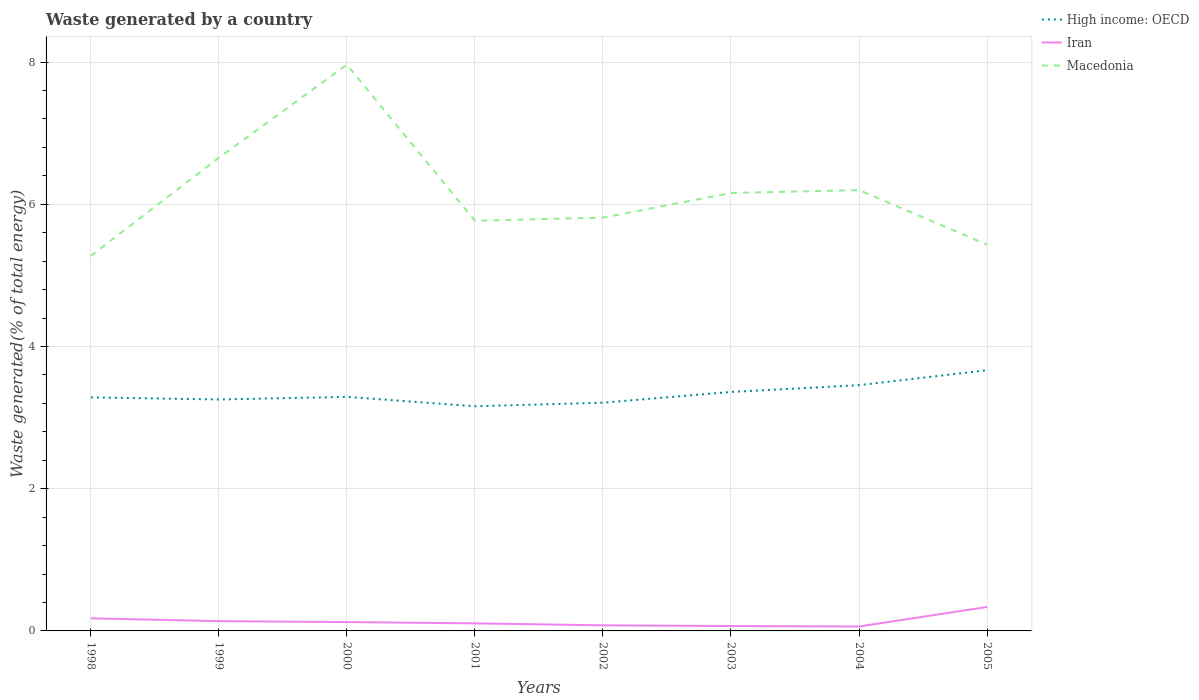Across all years, what is the maximum total waste generated in High income: OECD?
Ensure brevity in your answer.  3.16. What is the total total waste generated in Macedonia in the graph?
Give a very brief answer. -0.49. What is the difference between the highest and the second highest total waste generated in Macedonia?
Keep it short and to the point. 2.69. What is the difference between the highest and the lowest total waste generated in Iran?
Your answer should be compact. 3. Is the total waste generated in Macedonia strictly greater than the total waste generated in High income: OECD over the years?
Your answer should be compact. No. How many lines are there?
Provide a succinct answer. 3. How many years are there in the graph?
Ensure brevity in your answer.  8. What is the difference between two consecutive major ticks on the Y-axis?
Make the answer very short. 2. Where does the legend appear in the graph?
Your answer should be compact. Top right. How are the legend labels stacked?
Your response must be concise. Vertical. What is the title of the graph?
Offer a very short reply. Waste generated by a country. Does "Libya" appear as one of the legend labels in the graph?
Provide a succinct answer. No. What is the label or title of the Y-axis?
Ensure brevity in your answer.  Waste generated(% of total energy). What is the Waste generated(% of total energy) of High income: OECD in 1998?
Provide a short and direct response. 3.28. What is the Waste generated(% of total energy) in Iran in 1998?
Your response must be concise. 0.18. What is the Waste generated(% of total energy) of Macedonia in 1998?
Offer a very short reply. 5.27. What is the Waste generated(% of total energy) in High income: OECD in 1999?
Offer a terse response. 3.26. What is the Waste generated(% of total energy) of Iran in 1999?
Ensure brevity in your answer.  0.14. What is the Waste generated(% of total energy) in Macedonia in 1999?
Make the answer very short. 6.66. What is the Waste generated(% of total energy) in High income: OECD in 2000?
Provide a succinct answer. 3.29. What is the Waste generated(% of total energy) of Iran in 2000?
Offer a terse response. 0.12. What is the Waste generated(% of total energy) of Macedonia in 2000?
Offer a terse response. 7.96. What is the Waste generated(% of total energy) of High income: OECD in 2001?
Your response must be concise. 3.16. What is the Waste generated(% of total energy) of Iran in 2001?
Your answer should be very brief. 0.11. What is the Waste generated(% of total energy) in Macedonia in 2001?
Give a very brief answer. 5.77. What is the Waste generated(% of total energy) of High income: OECD in 2002?
Give a very brief answer. 3.21. What is the Waste generated(% of total energy) in Iran in 2002?
Offer a very short reply. 0.08. What is the Waste generated(% of total energy) of Macedonia in 2002?
Ensure brevity in your answer.  5.81. What is the Waste generated(% of total energy) of High income: OECD in 2003?
Your response must be concise. 3.36. What is the Waste generated(% of total energy) of Iran in 2003?
Your answer should be very brief. 0.07. What is the Waste generated(% of total energy) in Macedonia in 2003?
Make the answer very short. 6.16. What is the Waste generated(% of total energy) of High income: OECD in 2004?
Offer a very short reply. 3.46. What is the Waste generated(% of total energy) in Iran in 2004?
Your answer should be very brief. 0.06. What is the Waste generated(% of total energy) of Macedonia in 2004?
Provide a succinct answer. 6.2. What is the Waste generated(% of total energy) in High income: OECD in 2005?
Make the answer very short. 3.67. What is the Waste generated(% of total energy) of Iran in 2005?
Keep it short and to the point. 0.34. What is the Waste generated(% of total energy) of Macedonia in 2005?
Ensure brevity in your answer.  5.43. Across all years, what is the maximum Waste generated(% of total energy) in High income: OECD?
Your response must be concise. 3.67. Across all years, what is the maximum Waste generated(% of total energy) in Iran?
Your answer should be compact. 0.34. Across all years, what is the maximum Waste generated(% of total energy) in Macedonia?
Offer a very short reply. 7.96. Across all years, what is the minimum Waste generated(% of total energy) in High income: OECD?
Ensure brevity in your answer.  3.16. Across all years, what is the minimum Waste generated(% of total energy) of Iran?
Your answer should be very brief. 0.06. Across all years, what is the minimum Waste generated(% of total energy) of Macedonia?
Make the answer very short. 5.27. What is the total Waste generated(% of total energy) in High income: OECD in the graph?
Offer a terse response. 26.69. What is the total Waste generated(% of total energy) of Iran in the graph?
Ensure brevity in your answer.  1.09. What is the total Waste generated(% of total energy) in Macedonia in the graph?
Provide a short and direct response. 49.27. What is the difference between the Waste generated(% of total energy) in High income: OECD in 1998 and that in 1999?
Make the answer very short. 0.03. What is the difference between the Waste generated(% of total energy) in Iran in 1998 and that in 1999?
Give a very brief answer. 0.04. What is the difference between the Waste generated(% of total energy) of Macedonia in 1998 and that in 1999?
Your answer should be compact. -1.38. What is the difference between the Waste generated(% of total energy) in High income: OECD in 1998 and that in 2000?
Your response must be concise. -0.01. What is the difference between the Waste generated(% of total energy) in Iran in 1998 and that in 2000?
Make the answer very short. 0.05. What is the difference between the Waste generated(% of total energy) of Macedonia in 1998 and that in 2000?
Provide a short and direct response. -2.69. What is the difference between the Waste generated(% of total energy) in High income: OECD in 1998 and that in 2001?
Make the answer very short. 0.13. What is the difference between the Waste generated(% of total energy) in Iran in 1998 and that in 2001?
Offer a terse response. 0.07. What is the difference between the Waste generated(% of total energy) of Macedonia in 1998 and that in 2001?
Make the answer very short. -0.49. What is the difference between the Waste generated(% of total energy) in High income: OECD in 1998 and that in 2002?
Provide a short and direct response. 0.07. What is the difference between the Waste generated(% of total energy) in Iran in 1998 and that in 2002?
Your answer should be very brief. 0.1. What is the difference between the Waste generated(% of total energy) in Macedonia in 1998 and that in 2002?
Make the answer very short. -0.54. What is the difference between the Waste generated(% of total energy) in High income: OECD in 1998 and that in 2003?
Provide a succinct answer. -0.08. What is the difference between the Waste generated(% of total energy) in Iran in 1998 and that in 2003?
Make the answer very short. 0.11. What is the difference between the Waste generated(% of total energy) of Macedonia in 1998 and that in 2003?
Your answer should be compact. -0.88. What is the difference between the Waste generated(% of total energy) in High income: OECD in 1998 and that in 2004?
Your response must be concise. -0.17. What is the difference between the Waste generated(% of total energy) of Iran in 1998 and that in 2004?
Provide a short and direct response. 0.12. What is the difference between the Waste generated(% of total energy) of Macedonia in 1998 and that in 2004?
Provide a short and direct response. -0.93. What is the difference between the Waste generated(% of total energy) in High income: OECD in 1998 and that in 2005?
Ensure brevity in your answer.  -0.38. What is the difference between the Waste generated(% of total energy) of Iran in 1998 and that in 2005?
Your answer should be compact. -0.16. What is the difference between the Waste generated(% of total energy) of Macedonia in 1998 and that in 2005?
Keep it short and to the point. -0.16. What is the difference between the Waste generated(% of total energy) of High income: OECD in 1999 and that in 2000?
Your answer should be very brief. -0.04. What is the difference between the Waste generated(% of total energy) of Iran in 1999 and that in 2000?
Provide a succinct answer. 0.01. What is the difference between the Waste generated(% of total energy) in Macedonia in 1999 and that in 2000?
Your answer should be very brief. -1.31. What is the difference between the Waste generated(% of total energy) of High income: OECD in 1999 and that in 2001?
Keep it short and to the point. 0.1. What is the difference between the Waste generated(% of total energy) of Iran in 1999 and that in 2001?
Your response must be concise. 0.03. What is the difference between the Waste generated(% of total energy) of Macedonia in 1999 and that in 2001?
Offer a very short reply. 0.89. What is the difference between the Waste generated(% of total energy) in High income: OECD in 1999 and that in 2002?
Offer a terse response. 0.04. What is the difference between the Waste generated(% of total energy) in Iran in 1999 and that in 2002?
Provide a short and direct response. 0.06. What is the difference between the Waste generated(% of total energy) of Macedonia in 1999 and that in 2002?
Ensure brevity in your answer.  0.84. What is the difference between the Waste generated(% of total energy) of High income: OECD in 1999 and that in 2003?
Your response must be concise. -0.11. What is the difference between the Waste generated(% of total energy) of Iran in 1999 and that in 2003?
Make the answer very short. 0.07. What is the difference between the Waste generated(% of total energy) in Macedonia in 1999 and that in 2003?
Provide a short and direct response. 0.5. What is the difference between the Waste generated(% of total energy) in High income: OECD in 1999 and that in 2004?
Ensure brevity in your answer.  -0.2. What is the difference between the Waste generated(% of total energy) in Iran in 1999 and that in 2004?
Provide a succinct answer. 0.08. What is the difference between the Waste generated(% of total energy) of Macedonia in 1999 and that in 2004?
Offer a terse response. 0.46. What is the difference between the Waste generated(% of total energy) of High income: OECD in 1999 and that in 2005?
Provide a succinct answer. -0.41. What is the difference between the Waste generated(% of total energy) of Iran in 1999 and that in 2005?
Your answer should be compact. -0.2. What is the difference between the Waste generated(% of total energy) in Macedonia in 1999 and that in 2005?
Ensure brevity in your answer.  1.22. What is the difference between the Waste generated(% of total energy) in High income: OECD in 2000 and that in 2001?
Your answer should be compact. 0.13. What is the difference between the Waste generated(% of total energy) of Iran in 2000 and that in 2001?
Your answer should be very brief. 0.02. What is the difference between the Waste generated(% of total energy) in Macedonia in 2000 and that in 2001?
Your answer should be very brief. 2.2. What is the difference between the Waste generated(% of total energy) of High income: OECD in 2000 and that in 2002?
Your answer should be compact. 0.08. What is the difference between the Waste generated(% of total energy) of Iran in 2000 and that in 2002?
Offer a very short reply. 0.05. What is the difference between the Waste generated(% of total energy) in Macedonia in 2000 and that in 2002?
Give a very brief answer. 2.15. What is the difference between the Waste generated(% of total energy) in High income: OECD in 2000 and that in 2003?
Offer a terse response. -0.07. What is the difference between the Waste generated(% of total energy) in Iran in 2000 and that in 2003?
Ensure brevity in your answer.  0.06. What is the difference between the Waste generated(% of total energy) in Macedonia in 2000 and that in 2003?
Keep it short and to the point. 1.8. What is the difference between the Waste generated(% of total energy) in High income: OECD in 2000 and that in 2004?
Your answer should be compact. -0.16. What is the difference between the Waste generated(% of total energy) of Iran in 2000 and that in 2004?
Give a very brief answer. 0.06. What is the difference between the Waste generated(% of total energy) in Macedonia in 2000 and that in 2004?
Give a very brief answer. 1.76. What is the difference between the Waste generated(% of total energy) in High income: OECD in 2000 and that in 2005?
Provide a succinct answer. -0.37. What is the difference between the Waste generated(% of total energy) in Iran in 2000 and that in 2005?
Offer a terse response. -0.21. What is the difference between the Waste generated(% of total energy) in Macedonia in 2000 and that in 2005?
Your response must be concise. 2.53. What is the difference between the Waste generated(% of total energy) of High income: OECD in 2001 and that in 2002?
Your response must be concise. -0.05. What is the difference between the Waste generated(% of total energy) in Iran in 2001 and that in 2002?
Your answer should be compact. 0.03. What is the difference between the Waste generated(% of total energy) of Macedonia in 2001 and that in 2002?
Ensure brevity in your answer.  -0.04. What is the difference between the Waste generated(% of total energy) in High income: OECD in 2001 and that in 2003?
Your response must be concise. -0.2. What is the difference between the Waste generated(% of total energy) in Iran in 2001 and that in 2003?
Your response must be concise. 0.04. What is the difference between the Waste generated(% of total energy) of Macedonia in 2001 and that in 2003?
Give a very brief answer. -0.39. What is the difference between the Waste generated(% of total energy) in High income: OECD in 2001 and that in 2004?
Your response must be concise. -0.3. What is the difference between the Waste generated(% of total energy) of Iran in 2001 and that in 2004?
Offer a terse response. 0.04. What is the difference between the Waste generated(% of total energy) in Macedonia in 2001 and that in 2004?
Offer a very short reply. -0.43. What is the difference between the Waste generated(% of total energy) of High income: OECD in 2001 and that in 2005?
Keep it short and to the point. -0.51. What is the difference between the Waste generated(% of total energy) in Iran in 2001 and that in 2005?
Your answer should be compact. -0.23. What is the difference between the Waste generated(% of total energy) of Macedonia in 2001 and that in 2005?
Offer a very short reply. 0.34. What is the difference between the Waste generated(% of total energy) in High income: OECD in 2002 and that in 2003?
Your answer should be very brief. -0.15. What is the difference between the Waste generated(% of total energy) in Iran in 2002 and that in 2003?
Your response must be concise. 0.01. What is the difference between the Waste generated(% of total energy) in Macedonia in 2002 and that in 2003?
Keep it short and to the point. -0.35. What is the difference between the Waste generated(% of total energy) of High income: OECD in 2002 and that in 2004?
Your answer should be very brief. -0.25. What is the difference between the Waste generated(% of total energy) of Iran in 2002 and that in 2004?
Offer a terse response. 0.02. What is the difference between the Waste generated(% of total energy) in Macedonia in 2002 and that in 2004?
Keep it short and to the point. -0.39. What is the difference between the Waste generated(% of total energy) in High income: OECD in 2002 and that in 2005?
Provide a short and direct response. -0.46. What is the difference between the Waste generated(% of total energy) of Iran in 2002 and that in 2005?
Your answer should be compact. -0.26. What is the difference between the Waste generated(% of total energy) of Macedonia in 2002 and that in 2005?
Offer a terse response. 0.38. What is the difference between the Waste generated(% of total energy) in High income: OECD in 2003 and that in 2004?
Make the answer very short. -0.1. What is the difference between the Waste generated(% of total energy) of Iran in 2003 and that in 2004?
Give a very brief answer. 0.01. What is the difference between the Waste generated(% of total energy) in Macedonia in 2003 and that in 2004?
Your answer should be compact. -0.04. What is the difference between the Waste generated(% of total energy) of High income: OECD in 2003 and that in 2005?
Your answer should be very brief. -0.31. What is the difference between the Waste generated(% of total energy) of Iran in 2003 and that in 2005?
Your answer should be compact. -0.27. What is the difference between the Waste generated(% of total energy) of Macedonia in 2003 and that in 2005?
Offer a terse response. 0.73. What is the difference between the Waste generated(% of total energy) of High income: OECD in 2004 and that in 2005?
Make the answer very short. -0.21. What is the difference between the Waste generated(% of total energy) in Iran in 2004 and that in 2005?
Your response must be concise. -0.27. What is the difference between the Waste generated(% of total energy) in Macedonia in 2004 and that in 2005?
Provide a succinct answer. 0.77. What is the difference between the Waste generated(% of total energy) of High income: OECD in 1998 and the Waste generated(% of total energy) of Iran in 1999?
Provide a succinct answer. 3.15. What is the difference between the Waste generated(% of total energy) of High income: OECD in 1998 and the Waste generated(% of total energy) of Macedonia in 1999?
Offer a very short reply. -3.37. What is the difference between the Waste generated(% of total energy) of Iran in 1998 and the Waste generated(% of total energy) of Macedonia in 1999?
Keep it short and to the point. -6.48. What is the difference between the Waste generated(% of total energy) in High income: OECD in 1998 and the Waste generated(% of total energy) in Iran in 2000?
Offer a very short reply. 3.16. What is the difference between the Waste generated(% of total energy) in High income: OECD in 1998 and the Waste generated(% of total energy) in Macedonia in 2000?
Offer a very short reply. -4.68. What is the difference between the Waste generated(% of total energy) in Iran in 1998 and the Waste generated(% of total energy) in Macedonia in 2000?
Make the answer very short. -7.79. What is the difference between the Waste generated(% of total energy) of High income: OECD in 1998 and the Waste generated(% of total energy) of Iran in 2001?
Your response must be concise. 3.18. What is the difference between the Waste generated(% of total energy) in High income: OECD in 1998 and the Waste generated(% of total energy) in Macedonia in 2001?
Ensure brevity in your answer.  -2.48. What is the difference between the Waste generated(% of total energy) of Iran in 1998 and the Waste generated(% of total energy) of Macedonia in 2001?
Offer a terse response. -5.59. What is the difference between the Waste generated(% of total energy) in High income: OECD in 1998 and the Waste generated(% of total energy) in Iran in 2002?
Your answer should be very brief. 3.21. What is the difference between the Waste generated(% of total energy) of High income: OECD in 1998 and the Waste generated(% of total energy) of Macedonia in 2002?
Your answer should be compact. -2.53. What is the difference between the Waste generated(% of total energy) of Iran in 1998 and the Waste generated(% of total energy) of Macedonia in 2002?
Ensure brevity in your answer.  -5.64. What is the difference between the Waste generated(% of total energy) in High income: OECD in 1998 and the Waste generated(% of total energy) in Iran in 2003?
Your answer should be compact. 3.22. What is the difference between the Waste generated(% of total energy) in High income: OECD in 1998 and the Waste generated(% of total energy) in Macedonia in 2003?
Ensure brevity in your answer.  -2.87. What is the difference between the Waste generated(% of total energy) in Iran in 1998 and the Waste generated(% of total energy) in Macedonia in 2003?
Your answer should be very brief. -5.98. What is the difference between the Waste generated(% of total energy) of High income: OECD in 1998 and the Waste generated(% of total energy) of Iran in 2004?
Your answer should be very brief. 3.22. What is the difference between the Waste generated(% of total energy) of High income: OECD in 1998 and the Waste generated(% of total energy) of Macedonia in 2004?
Make the answer very short. -2.92. What is the difference between the Waste generated(% of total energy) of Iran in 1998 and the Waste generated(% of total energy) of Macedonia in 2004?
Provide a succinct answer. -6.02. What is the difference between the Waste generated(% of total energy) in High income: OECD in 1998 and the Waste generated(% of total energy) in Iran in 2005?
Your answer should be very brief. 2.95. What is the difference between the Waste generated(% of total energy) in High income: OECD in 1998 and the Waste generated(% of total energy) in Macedonia in 2005?
Offer a terse response. -2.15. What is the difference between the Waste generated(% of total energy) of Iran in 1998 and the Waste generated(% of total energy) of Macedonia in 2005?
Ensure brevity in your answer.  -5.26. What is the difference between the Waste generated(% of total energy) in High income: OECD in 1999 and the Waste generated(% of total energy) in Iran in 2000?
Give a very brief answer. 3.13. What is the difference between the Waste generated(% of total energy) in High income: OECD in 1999 and the Waste generated(% of total energy) in Macedonia in 2000?
Your answer should be compact. -4.71. What is the difference between the Waste generated(% of total energy) of Iran in 1999 and the Waste generated(% of total energy) of Macedonia in 2000?
Offer a very short reply. -7.83. What is the difference between the Waste generated(% of total energy) of High income: OECD in 1999 and the Waste generated(% of total energy) of Iran in 2001?
Offer a terse response. 3.15. What is the difference between the Waste generated(% of total energy) of High income: OECD in 1999 and the Waste generated(% of total energy) of Macedonia in 2001?
Your response must be concise. -2.51. What is the difference between the Waste generated(% of total energy) of Iran in 1999 and the Waste generated(% of total energy) of Macedonia in 2001?
Provide a succinct answer. -5.63. What is the difference between the Waste generated(% of total energy) in High income: OECD in 1999 and the Waste generated(% of total energy) in Iran in 2002?
Give a very brief answer. 3.18. What is the difference between the Waste generated(% of total energy) in High income: OECD in 1999 and the Waste generated(% of total energy) in Macedonia in 2002?
Your response must be concise. -2.56. What is the difference between the Waste generated(% of total energy) in Iran in 1999 and the Waste generated(% of total energy) in Macedonia in 2002?
Give a very brief answer. -5.67. What is the difference between the Waste generated(% of total energy) in High income: OECD in 1999 and the Waste generated(% of total energy) in Iran in 2003?
Give a very brief answer. 3.19. What is the difference between the Waste generated(% of total energy) of High income: OECD in 1999 and the Waste generated(% of total energy) of Macedonia in 2003?
Give a very brief answer. -2.9. What is the difference between the Waste generated(% of total energy) of Iran in 1999 and the Waste generated(% of total energy) of Macedonia in 2003?
Your response must be concise. -6.02. What is the difference between the Waste generated(% of total energy) in High income: OECD in 1999 and the Waste generated(% of total energy) in Iran in 2004?
Give a very brief answer. 3.19. What is the difference between the Waste generated(% of total energy) of High income: OECD in 1999 and the Waste generated(% of total energy) of Macedonia in 2004?
Make the answer very short. -2.94. What is the difference between the Waste generated(% of total energy) in Iran in 1999 and the Waste generated(% of total energy) in Macedonia in 2004?
Give a very brief answer. -6.06. What is the difference between the Waste generated(% of total energy) of High income: OECD in 1999 and the Waste generated(% of total energy) of Iran in 2005?
Keep it short and to the point. 2.92. What is the difference between the Waste generated(% of total energy) of High income: OECD in 1999 and the Waste generated(% of total energy) of Macedonia in 2005?
Offer a very short reply. -2.18. What is the difference between the Waste generated(% of total energy) of Iran in 1999 and the Waste generated(% of total energy) of Macedonia in 2005?
Your answer should be compact. -5.3. What is the difference between the Waste generated(% of total energy) of High income: OECD in 2000 and the Waste generated(% of total energy) of Iran in 2001?
Offer a terse response. 3.19. What is the difference between the Waste generated(% of total energy) in High income: OECD in 2000 and the Waste generated(% of total energy) in Macedonia in 2001?
Keep it short and to the point. -2.48. What is the difference between the Waste generated(% of total energy) of Iran in 2000 and the Waste generated(% of total energy) of Macedonia in 2001?
Offer a terse response. -5.64. What is the difference between the Waste generated(% of total energy) of High income: OECD in 2000 and the Waste generated(% of total energy) of Iran in 2002?
Make the answer very short. 3.21. What is the difference between the Waste generated(% of total energy) of High income: OECD in 2000 and the Waste generated(% of total energy) of Macedonia in 2002?
Offer a terse response. -2.52. What is the difference between the Waste generated(% of total energy) of Iran in 2000 and the Waste generated(% of total energy) of Macedonia in 2002?
Keep it short and to the point. -5.69. What is the difference between the Waste generated(% of total energy) in High income: OECD in 2000 and the Waste generated(% of total energy) in Iran in 2003?
Ensure brevity in your answer.  3.22. What is the difference between the Waste generated(% of total energy) in High income: OECD in 2000 and the Waste generated(% of total energy) in Macedonia in 2003?
Make the answer very short. -2.87. What is the difference between the Waste generated(% of total energy) of Iran in 2000 and the Waste generated(% of total energy) of Macedonia in 2003?
Your answer should be very brief. -6.03. What is the difference between the Waste generated(% of total energy) of High income: OECD in 2000 and the Waste generated(% of total energy) of Iran in 2004?
Keep it short and to the point. 3.23. What is the difference between the Waste generated(% of total energy) in High income: OECD in 2000 and the Waste generated(% of total energy) in Macedonia in 2004?
Ensure brevity in your answer.  -2.91. What is the difference between the Waste generated(% of total energy) in Iran in 2000 and the Waste generated(% of total energy) in Macedonia in 2004?
Your answer should be compact. -6.08. What is the difference between the Waste generated(% of total energy) in High income: OECD in 2000 and the Waste generated(% of total energy) in Iran in 2005?
Your answer should be compact. 2.96. What is the difference between the Waste generated(% of total energy) in High income: OECD in 2000 and the Waste generated(% of total energy) in Macedonia in 2005?
Offer a very short reply. -2.14. What is the difference between the Waste generated(% of total energy) in Iran in 2000 and the Waste generated(% of total energy) in Macedonia in 2005?
Your answer should be compact. -5.31. What is the difference between the Waste generated(% of total energy) of High income: OECD in 2001 and the Waste generated(% of total energy) of Iran in 2002?
Offer a very short reply. 3.08. What is the difference between the Waste generated(% of total energy) in High income: OECD in 2001 and the Waste generated(% of total energy) in Macedonia in 2002?
Keep it short and to the point. -2.65. What is the difference between the Waste generated(% of total energy) of Iran in 2001 and the Waste generated(% of total energy) of Macedonia in 2002?
Provide a short and direct response. -5.71. What is the difference between the Waste generated(% of total energy) in High income: OECD in 2001 and the Waste generated(% of total energy) in Iran in 2003?
Your response must be concise. 3.09. What is the difference between the Waste generated(% of total energy) in High income: OECD in 2001 and the Waste generated(% of total energy) in Macedonia in 2003?
Make the answer very short. -3. What is the difference between the Waste generated(% of total energy) of Iran in 2001 and the Waste generated(% of total energy) of Macedonia in 2003?
Provide a succinct answer. -6.05. What is the difference between the Waste generated(% of total energy) in High income: OECD in 2001 and the Waste generated(% of total energy) in Iran in 2004?
Your response must be concise. 3.1. What is the difference between the Waste generated(% of total energy) in High income: OECD in 2001 and the Waste generated(% of total energy) in Macedonia in 2004?
Keep it short and to the point. -3.04. What is the difference between the Waste generated(% of total energy) in Iran in 2001 and the Waste generated(% of total energy) in Macedonia in 2004?
Your response must be concise. -6.09. What is the difference between the Waste generated(% of total energy) of High income: OECD in 2001 and the Waste generated(% of total energy) of Iran in 2005?
Keep it short and to the point. 2.82. What is the difference between the Waste generated(% of total energy) in High income: OECD in 2001 and the Waste generated(% of total energy) in Macedonia in 2005?
Your response must be concise. -2.27. What is the difference between the Waste generated(% of total energy) of Iran in 2001 and the Waste generated(% of total energy) of Macedonia in 2005?
Your answer should be compact. -5.33. What is the difference between the Waste generated(% of total energy) of High income: OECD in 2002 and the Waste generated(% of total energy) of Iran in 2003?
Provide a succinct answer. 3.14. What is the difference between the Waste generated(% of total energy) in High income: OECD in 2002 and the Waste generated(% of total energy) in Macedonia in 2003?
Ensure brevity in your answer.  -2.95. What is the difference between the Waste generated(% of total energy) in Iran in 2002 and the Waste generated(% of total energy) in Macedonia in 2003?
Offer a very short reply. -6.08. What is the difference between the Waste generated(% of total energy) of High income: OECD in 2002 and the Waste generated(% of total energy) of Iran in 2004?
Keep it short and to the point. 3.15. What is the difference between the Waste generated(% of total energy) of High income: OECD in 2002 and the Waste generated(% of total energy) of Macedonia in 2004?
Provide a succinct answer. -2.99. What is the difference between the Waste generated(% of total energy) of Iran in 2002 and the Waste generated(% of total energy) of Macedonia in 2004?
Your answer should be compact. -6.12. What is the difference between the Waste generated(% of total energy) of High income: OECD in 2002 and the Waste generated(% of total energy) of Iran in 2005?
Ensure brevity in your answer.  2.87. What is the difference between the Waste generated(% of total energy) of High income: OECD in 2002 and the Waste generated(% of total energy) of Macedonia in 2005?
Ensure brevity in your answer.  -2.22. What is the difference between the Waste generated(% of total energy) in Iran in 2002 and the Waste generated(% of total energy) in Macedonia in 2005?
Your response must be concise. -5.36. What is the difference between the Waste generated(% of total energy) of High income: OECD in 2003 and the Waste generated(% of total energy) of Iran in 2004?
Keep it short and to the point. 3.3. What is the difference between the Waste generated(% of total energy) in High income: OECD in 2003 and the Waste generated(% of total energy) in Macedonia in 2004?
Make the answer very short. -2.84. What is the difference between the Waste generated(% of total energy) of Iran in 2003 and the Waste generated(% of total energy) of Macedonia in 2004?
Your response must be concise. -6.13. What is the difference between the Waste generated(% of total energy) in High income: OECD in 2003 and the Waste generated(% of total energy) in Iran in 2005?
Provide a short and direct response. 3.02. What is the difference between the Waste generated(% of total energy) of High income: OECD in 2003 and the Waste generated(% of total energy) of Macedonia in 2005?
Offer a terse response. -2.07. What is the difference between the Waste generated(% of total energy) in Iran in 2003 and the Waste generated(% of total energy) in Macedonia in 2005?
Ensure brevity in your answer.  -5.36. What is the difference between the Waste generated(% of total energy) in High income: OECD in 2004 and the Waste generated(% of total energy) in Iran in 2005?
Your answer should be very brief. 3.12. What is the difference between the Waste generated(% of total energy) of High income: OECD in 2004 and the Waste generated(% of total energy) of Macedonia in 2005?
Provide a short and direct response. -1.98. What is the difference between the Waste generated(% of total energy) of Iran in 2004 and the Waste generated(% of total energy) of Macedonia in 2005?
Provide a succinct answer. -5.37. What is the average Waste generated(% of total energy) of High income: OECD per year?
Your response must be concise. 3.34. What is the average Waste generated(% of total energy) in Iran per year?
Your answer should be very brief. 0.14. What is the average Waste generated(% of total energy) of Macedonia per year?
Your answer should be compact. 6.16. In the year 1998, what is the difference between the Waste generated(% of total energy) of High income: OECD and Waste generated(% of total energy) of Iran?
Provide a succinct answer. 3.11. In the year 1998, what is the difference between the Waste generated(% of total energy) in High income: OECD and Waste generated(% of total energy) in Macedonia?
Offer a very short reply. -1.99. In the year 1998, what is the difference between the Waste generated(% of total energy) in Iran and Waste generated(% of total energy) in Macedonia?
Your response must be concise. -5.1. In the year 1999, what is the difference between the Waste generated(% of total energy) of High income: OECD and Waste generated(% of total energy) of Iran?
Make the answer very short. 3.12. In the year 1999, what is the difference between the Waste generated(% of total energy) of High income: OECD and Waste generated(% of total energy) of Macedonia?
Your response must be concise. -3.4. In the year 1999, what is the difference between the Waste generated(% of total energy) in Iran and Waste generated(% of total energy) in Macedonia?
Keep it short and to the point. -6.52. In the year 2000, what is the difference between the Waste generated(% of total energy) of High income: OECD and Waste generated(% of total energy) of Iran?
Ensure brevity in your answer.  3.17. In the year 2000, what is the difference between the Waste generated(% of total energy) in High income: OECD and Waste generated(% of total energy) in Macedonia?
Make the answer very short. -4.67. In the year 2000, what is the difference between the Waste generated(% of total energy) in Iran and Waste generated(% of total energy) in Macedonia?
Provide a short and direct response. -7.84. In the year 2001, what is the difference between the Waste generated(% of total energy) of High income: OECD and Waste generated(% of total energy) of Iran?
Ensure brevity in your answer.  3.05. In the year 2001, what is the difference between the Waste generated(% of total energy) in High income: OECD and Waste generated(% of total energy) in Macedonia?
Your answer should be very brief. -2.61. In the year 2001, what is the difference between the Waste generated(% of total energy) in Iran and Waste generated(% of total energy) in Macedonia?
Your response must be concise. -5.66. In the year 2002, what is the difference between the Waste generated(% of total energy) in High income: OECD and Waste generated(% of total energy) in Iran?
Ensure brevity in your answer.  3.13. In the year 2002, what is the difference between the Waste generated(% of total energy) in High income: OECD and Waste generated(% of total energy) in Macedonia?
Offer a very short reply. -2.6. In the year 2002, what is the difference between the Waste generated(% of total energy) in Iran and Waste generated(% of total energy) in Macedonia?
Your response must be concise. -5.73. In the year 2003, what is the difference between the Waste generated(% of total energy) in High income: OECD and Waste generated(% of total energy) in Iran?
Keep it short and to the point. 3.29. In the year 2003, what is the difference between the Waste generated(% of total energy) in High income: OECD and Waste generated(% of total energy) in Macedonia?
Your answer should be very brief. -2.8. In the year 2003, what is the difference between the Waste generated(% of total energy) of Iran and Waste generated(% of total energy) of Macedonia?
Your response must be concise. -6.09. In the year 2004, what is the difference between the Waste generated(% of total energy) of High income: OECD and Waste generated(% of total energy) of Iran?
Your answer should be very brief. 3.39. In the year 2004, what is the difference between the Waste generated(% of total energy) of High income: OECD and Waste generated(% of total energy) of Macedonia?
Your answer should be very brief. -2.74. In the year 2004, what is the difference between the Waste generated(% of total energy) in Iran and Waste generated(% of total energy) in Macedonia?
Offer a terse response. -6.14. In the year 2005, what is the difference between the Waste generated(% of total energy) of High income: OECD and Waste generated(% of total energy) of Iran?
Keep it short and to the point. 3.33. In the year 2005, what is the difference between the Waste generated(% of total energy) in High income: OECD and Waste generated(% of total energy) in Macedonia?
Provide a succinct answer. -1.77. In the year 2005, what is the difference between the Waste generated(% of total energy) of Iran and Waste generated(% of total energy) of Macedonia?
Offer a very short reply. -5.1. What is the ratio of the Waste generated(% of total energy) in High income: OECD in 1998 to that in 1999?
Offer a terse response. 1.01. What is the ratio of the Waste generated(% of total energy) of Iran in 1998 to that in 1999?
Ensure brevity in your answer.  1.29. What is the ratio of the Waste generated(% of total energy) in Macedonia in 1998 to that in 1999?
Your answer should be compact. 0.79. What is the ratio of the Waste generated(% of total energy) in Iran in 1998 to that in 2000?
Ensure brevity in your answer.  1.43. What is the ratio of the Waste generated(% of total energy) in Macedonia in 1998 to that in 2000?
Your response must be concise. 0.66. What is the ratio of the Waste generated(% of total energy) of High income: OECD in 1998 to that in 2001?
Keep it short and to the point. 1.04. What is the ratio of the Waste generated(% of total energy) of Iran in 1998 to that in 2001?
Ensure brevity in your answer.  1.66. What is the ratio of the Waste generated(% of total energy) of Macedonia in 1998 to that in 2001?
Provide a short and direct response. 0.91. What is the ratio of the Waste generated(% of total energy) of High income: OECD in 1998 to that in 2002?
Your answer should be compact. 1.02. What is the ratio of the Waste generated(% of total energy) in Iran in 1998 to that in 2002?
Offer a very short reply. 2.26. What is the ratio of the Waste generated(% of total energy) in Macedonia in 1998 to that in 2002?
Your answer should be very brief. 0.91. What is the ratio of the Waste generated(% of total energy) of High income: OECD in 1998 to that in 2003?
Provide a short and direct response. 0.98. What is the ratio of the Waste generated(% of total energy) of Iran in 1998 to that in 2003?
Offer a very short reply. 2.58. What is the ratio of the Waste generated(% of total energy) of Macedonia in 1998 to that in 2003?
Give a very brief answer. 0.86. What is the ratio of the Waste generated(% of total energy) of High income: OECD in 1998 to that in 2004?
Give a very brief answer. 0.95. What is the ratio of the Waste generated(% of total energy) of Iran in 1998 to that in 2004?
Offer a terse response. 2.85. What is the ratio of the Waste generated(% of total energy) of Macedonia in 1998 to that in 2004?
Provide a short and direct response. 0.85. What is the ratio of the Waste generated(% of total energy) in High income: OECD in 1998 to that in 2005?
Ensure brevity in your answer.  0.9. What is the ratio of the Waste generated(% of total energy) of Iran in 1998 to that in 2005?
Your response must be concise. 0.53. What is the ratio of the Waste generated(% of total energy) in Macedonia in 1998 to that in 2005?
Your response must be concise. 0.97. What is the ratio of the Waste generated(% of total energy) in Iran in 1999 to that in 2000?
Your response must be concise. 1.11. What is the ratio of the Waste generated(% of total energy) in Macedonia in 1999 to that in 2000?
Give a very brief answer. 0.84. What is the ratio of the Waste generated(% of total energy) in High income: OECD in 1999 to that in 2001?
Offer a terse response. 1.03. What is the ratio of the Waste generated(% of total energy) in Iran in 1999 to that in 2001?
Offer a very short reply. 1.29. What is the ratio of the Waste generated(% of total energy) of Macedonia in 1999 to that in 2001?
Offer a very short reply. 1.15. What is the ratio of the Waste generated(% of total energy) of High income: OECD in 1999 to that in 2002?
Offer a very short reply. 1.01. What is the ratio of the Waste generated(% of total energy) in Iran in 1999 to that in 2002?
Offer a terse response. 1.76. What is the ratio of the Waste generated(% of total energy) in Macedonia in 1999 to that in 2002?
Your response must be concise. 1.15. What is the ratio of the Waste generated(% of total energy) in High income: OECD in 1999 to that in 2003?
Your answer should be very brief. 0.97. What is the ratio of the Waste generated(% of total energy) in Iran in 1999 to that in 2003?
Your answer should be compact. 2. What is the ratio of the Waste generated(% of total energy) of Macedonia in 1999 to that in 2003?
Your answer should be compact. 1.08. What is the ratio of the Waste generated(% of total energy) of High income: OECD in 1999 to that in 2004?
Give a very brief answer. 0.94. What is the ratio of the Waste generated(% of total energy) of Iran in 1999 to that in 2004?
Give a very brief answer. 2.21. What is the ratio of the Waste generated(% of total energy) in Macedonia in 1999 to that in 2004?
Your answer should be very brief. 1.07. What is the ratio of the Waste generated(% of total energy) in High income: OECD in 1999 to that in 2005?
Keep it short and to the point. 0.89. What is the ratio of the Waste generated(% of total energy) of Iran in 1999 to that in 2005?
Your answer should be compact. 0.41. What is the ratio of the Waste generated(% of total energy) of Macedonia in 1999 to that in 2005?
Your answer should be compact. 1.22. What is the ratio of the Waste generated(% of total energy) in High income: OECD in 2000 to that in 2001?
Offer a very short reply. 1.04. What is the ratio of the Waste generated(% of total energy) in Iran in 2000 to that in 2001?
Offer a terse response. 1.17. What is the ratio of the Waste generated(% of total energy) of Macedonia in 2000 to that in 2001?
Provide a short and direct response. 1.38. What is the ratio of the Waste generated(% of total energy) of High income: OECD in 2000 to that in 2002?
Provide a succinct answer. 1.03. What is the ratio of the Waste generated(% of total energy) in Iran in 2000 to that in 2002?
Offer a terse response. 1.59. What is the ratio of the Waste generated(% of total energy) in Macedonia in 2000 to that in 2002?
Your answer should be very brief. 1.37. What is the ratio of the Waste generated(% of total energy) of High income: OECD in 2000 to that in 2003?
Your answer should be compact. 0.98. What is the ratio of the Waste generated(% of total energy) of Iran in 2000 to that in 2003?
Your answer should be compact. 1.81. What is the ratio of the Waste generated(% of total energy) of Macedonia in 2000 to that in 2003?
Provide a short and direct response. 1.29. What is the ratio of the Waste generated(% of total energy) of Iran in 2000 to that in 2004?
Ensure brevity in your answer.  2. What is the ratio of the Waste generated(% of total energy) in Macedonia in 2000 to that in 2004?
Make the answer very short. 1.28. What is the ratio of the Waste generated(% of total energy) in High income: OECD in 2000 to that in 2005?
Make the answer very short. 0.9. What is the ratio of the Waste generated(% of total energy) of Iran in 2000 to that in 2005?
Make the answer very short. 0.37. What is the ratio of the Waste generated(% of total energy) of Macedonia in 2000 to that in 2005?
Offer a very short reply. 1.47. What is the ratio of the Waste generated(% of total energy) in High income: OECD in 2001 to that in 2002?
Ensure brevity in your answer.  0.98. What is the ratio of the Waste generated(% of total energy) of Iran in 2001 to that in 2002?
Provide a succinct answer. 1.36. What is the ratio of the Waste generated(% of total energy) in High income: OECD in 2001 to that in 2003?
Your answer should be compact. 0.94. What is the ratio of the Waste generated(% of total energy) in Iran in 2001 to that in 2003?
Your response must be concise. 1.55. What is the ratio of the Waste generated(% of total energy) of Macedonia in 2001 to that in 2003?
Keep it short and to the point. 0.94. What is the ratio of the Waste generated(% of total energy) in High income: OECD in 2001 to that in 2004?
Offer a very short reply. 0.91. What is the ratio of the Waste generated(% of total energy) in Iran in 2001 to that in 2004?
Give a very brief answer. 1.71. What is the ratio of the Waste generated(% of total energy) of Macedonia in 2001 to that in 2004?
Offer a very short reply. 0.93. What is the ratio of the Waste generated(% of total energy) of High income: OECD in 2001 to that in 2005?
Provide a succinct answer. 0.86. What is the ratio of the Waste generated(% of total energy) of Iran in 2001 to that in 2005?
Offer a terse response. 0.32. What is the ratio of the Waste generated(% of total energy) of Macedonia in 2001 to that in 2005?
Ensure brevity in your answer.  1.06. What is the ratio of the Waste generated(% of total energy) of High income: OECD in 2002 to that in 2003?
Ensure brevity in your answer.  0.96. What is the ratio of the Waste generated(% of total energy) in Iran in 2002 to that in 2003?
Ensure brevity in your answer.  1.14. What is the ratio of the Waste generated(% of total energy) of Macedonia in 2002 to that in 2003?
Make the answer very short. 0.94. What is the ratio of the Waste generated(% of total energy) of High income: OECD in 2002 to that in 2004?
Offer a very short reply. 0.93. What is the ratio of the Waste generated(% of total energy) of Iran in 2002 to that in 2004?
Provide a succinct answer. 1.26. What is the ratio of the Waste generated(% of total energy) of Macedonia in 2002 to that in 2004?
Your answer should be very brief. 0.94. What is the ratio of the Waste generated(% of total energy) in High income: OECD in 2002 to that in 2005?
Your response must be concise. 0.88. What is the ratio of the Waste generated(% of total energy) of Iran in 2002 to that in 2005?
Offer a very short reply. 0.23. What is the ratio of the Waste generated(% of total energy) of Macedonia in 2002 to that in 2005?
Ensure brevity in your answer.  1.07. What is the ratio of the Waste generated(% of total energy) in High income: OECD in 2003 to that in 2004?
Offer a terse response. 0.97. What is the ratio of the Waste generated(% of total energy) of Iran in 2003 to that in 2004?
Make the answer very short. 1.11. What is the ratio of the Waste generated(% of total energy) in Macedonia in 2003 to that in 2004?
Offer a very short reply. 0.99. What is the ratio of the Waste generated(% of total energy) in High income: OECD in 2003 to that in 2005?
Give a very brief answer. 0.92. What is the ratio of the Waste generated(% of total energy) of Iran in 2003 to that in 2005?
Offer a terse response. 0.2. What is the ratio of the Waste generated(% of total energy) in Macedonia in 2003 to that in 2005?
Provide a short and direct response. 1.13. What is the ratio of the Waste generated(% of total energy) of High income: OECD in 2004 to that in 2005?
Ensure brevity in your answer.  0.94. What is the ratio of the Waste generated(% of total energy) in Iran in 2004 to that in 2005?
Your answer should be compact. 0.18. What is the ratio of the Waste generated(% of total energy) in Macedonia in 2004 to that in 2005?
Offer a terse response. 1.14. What is the difference between the highest and the second highest Waste generated(% of total energy) of High income: OECD?
Keep it short and to the point. 0.21. What is the difference between the highest and the second highest Waste generated(% of total energy) in Iran?
Make the answer very short. 0.16. What is the difference between the highest and the second highest Waste generated(% of total energy) of Macedonia?
Offer a very short reply. 1.31. What is the difference between the highest and the lowest Waste generated(% of total energy) of High income: OECD?
Provide a succinct answer. 0.51. What is the difference between the highest and the lowest Waste generated(% of total energy) in Iran?
Keep it short and to the point. 0.27. What is the difference between the highest and the lowest Waste generated(% of total energy) of Macedonia?
Ensure brevity in your answer.  2.69. 